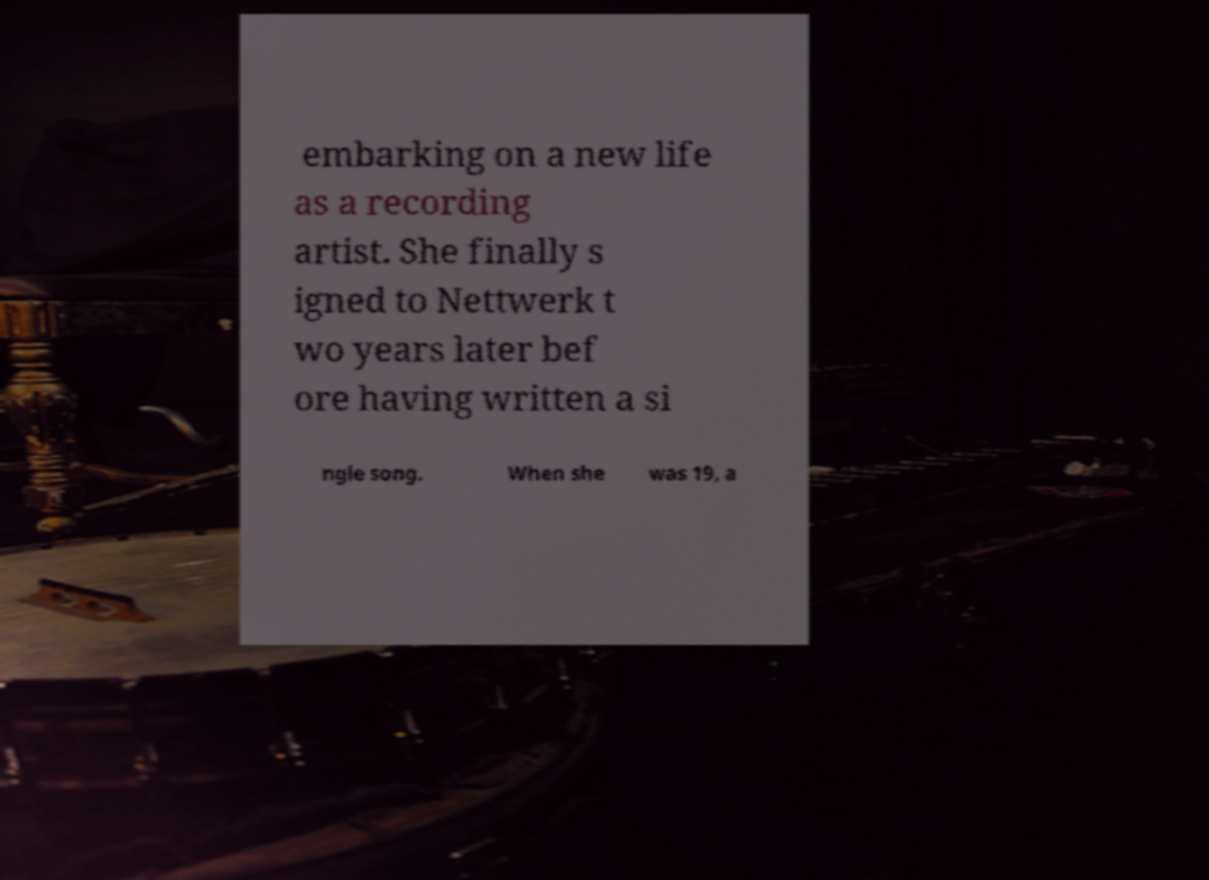For documentation purposes, I need the text within this image transcribed. Could you provide that? embarking on a new life as a recording artist. She finally s igned to Nettwerk t wo years later bef ore having written a si ngle song. When she was 19, a 